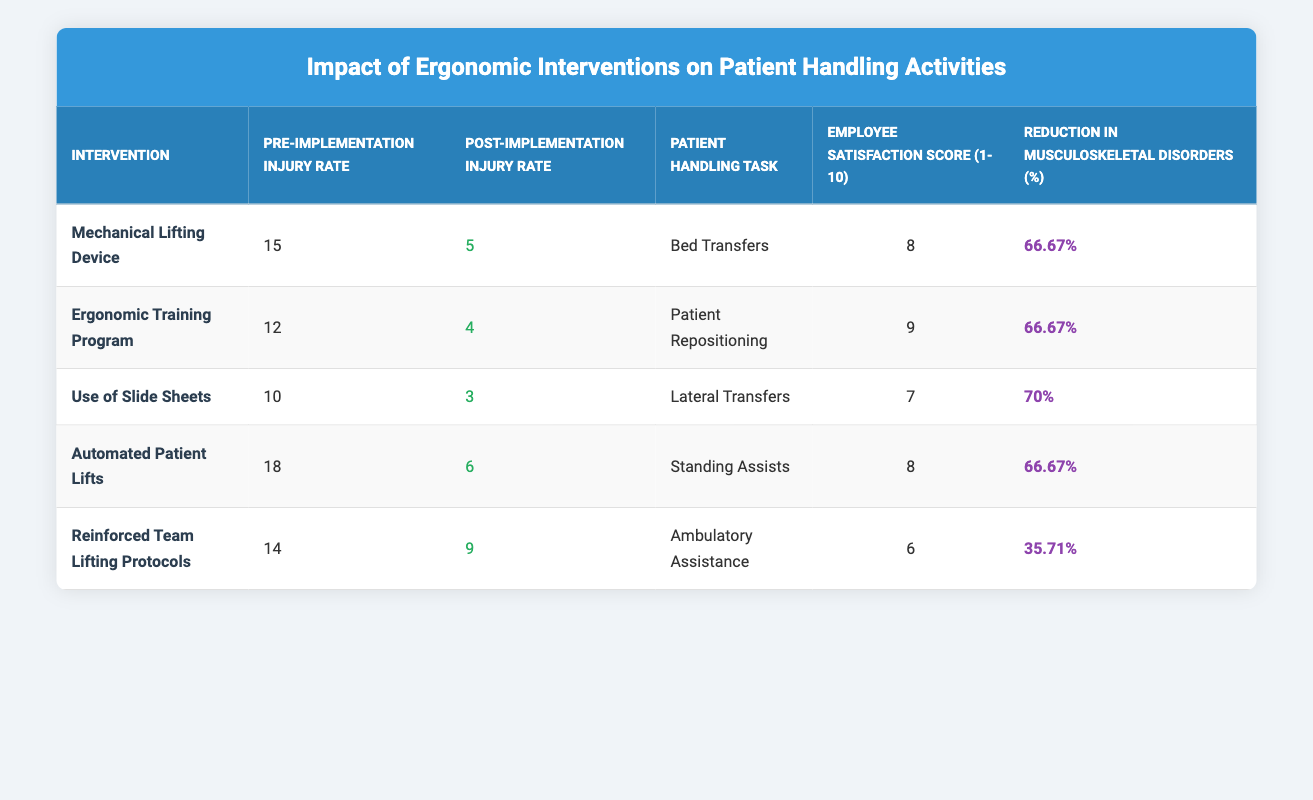What was the Pre-Implementation Injury Rate for the Ergonomic Training Program? According to the table, the Pre-Implementation Injury Rate for the Ergonomic Training Program is listed as 12.
Answer: 12 Which intervention had the highest Post-Implementation Injury Rate? Looking through the Post-Implementation Injury Rates, the Automated Patient Lifts has the highest rate at 6.
Answer: 6 What is the average Employee Satisfaction Score for all interventions? To find the average, we add the scores: (8 + 9 + 7 + 8 + 6) = 38. Since there are 5 interventions, we divide 38 by 5, giving us an average score of 7.6.
Answer: 7.6 Was there a reduction in Musculoskeletal Disorders greater than 50% for all interventions? Examining the Reduction in Musculoskeletal Disorders, four interventions (Mechanical Lifting Device, Ergonomic Training Program, Use of Slide Sheets, and Automated Patient Lifts) show a reduction greater than 50%. Thus, the answer is yes.
Answer: Yes Which Patient Handling Task showed the greatest reduction (%) in injuries after implementing an ergonomic intervention? From the table, the Use of Slide Sheets had a reduction of 70%, which is the highest percentage compared to other interventions. Thus, Lateral Transfers showed the greatest reduction.
Answer: Lateral Transfers What was the percentage reduction in musculoskeletal disorders for the Reinforced Team Lifting Protocols? The table indicates that the Reinforced Team Lifting Protocols had a reduction in musculoskeletal disorders of 35.71%.
Answer: 35.71% How many interventions resulted in a 66.67% reduction in musculoskeletal disorders? By examining the table, we find that three interventions (Mechanical Lifting Device, Ergonomic Training Program, and Automated Patient Lifts) achieved a reduction of 66.67%.
Answer: 3 Is the Employee Satisfaction Score for any intervention below 7? Checking the Employee Satisfaction Scores in the table, the Reinforced Team Lifting Protocols scored a 6, which is below 7, so the answer is yes.
Answer: Yes Which intervention had the lowest Pre-Implementation Injury Rate? Looking at the table, the Use of Slide Sheets had the lowest Pre-Implementation Injury Rate at 10 compared to other interventions.
Answer: 10 